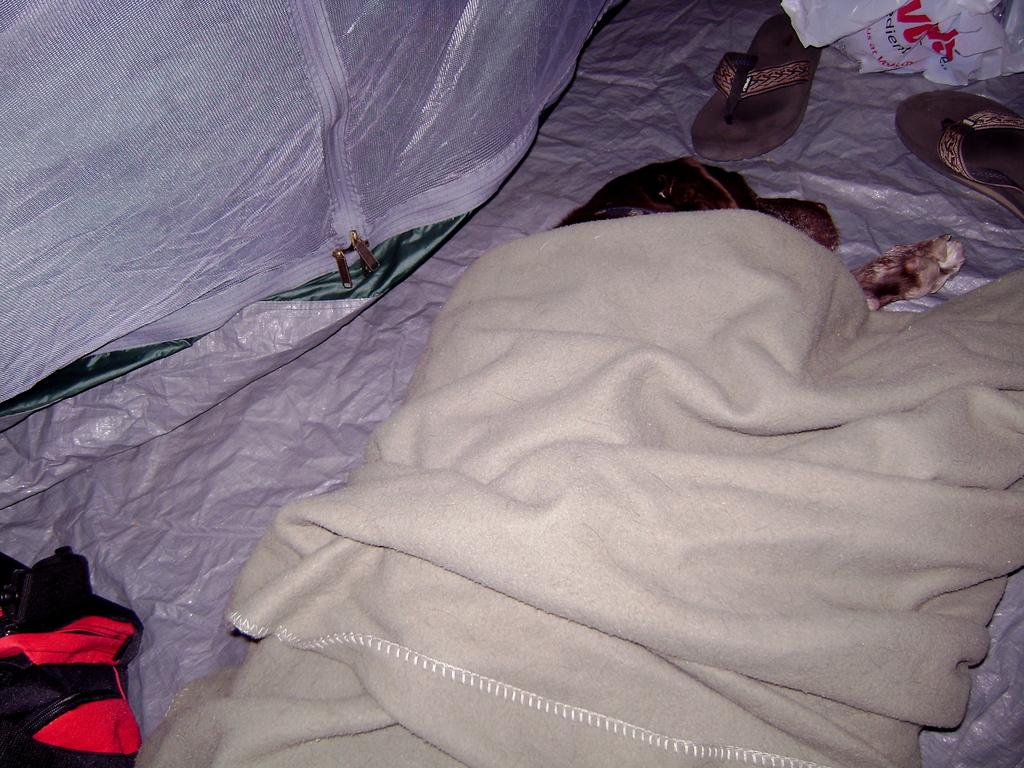What type of animal is present in the image? There is a dog in the image. What is the dog doing in the image? The dog is sleeping. Is there anything covering the dog in the image? Yes, there is a cloth covering the dog. What else can be seen in front of the dog? There is a pair of footwear in front of the dog. What language is being spoken during the discussion in the image? There is no discussion or language spoken in the image; it only shows a sleeping dog with a cloth covering it and a pair of footwear in front of it. 